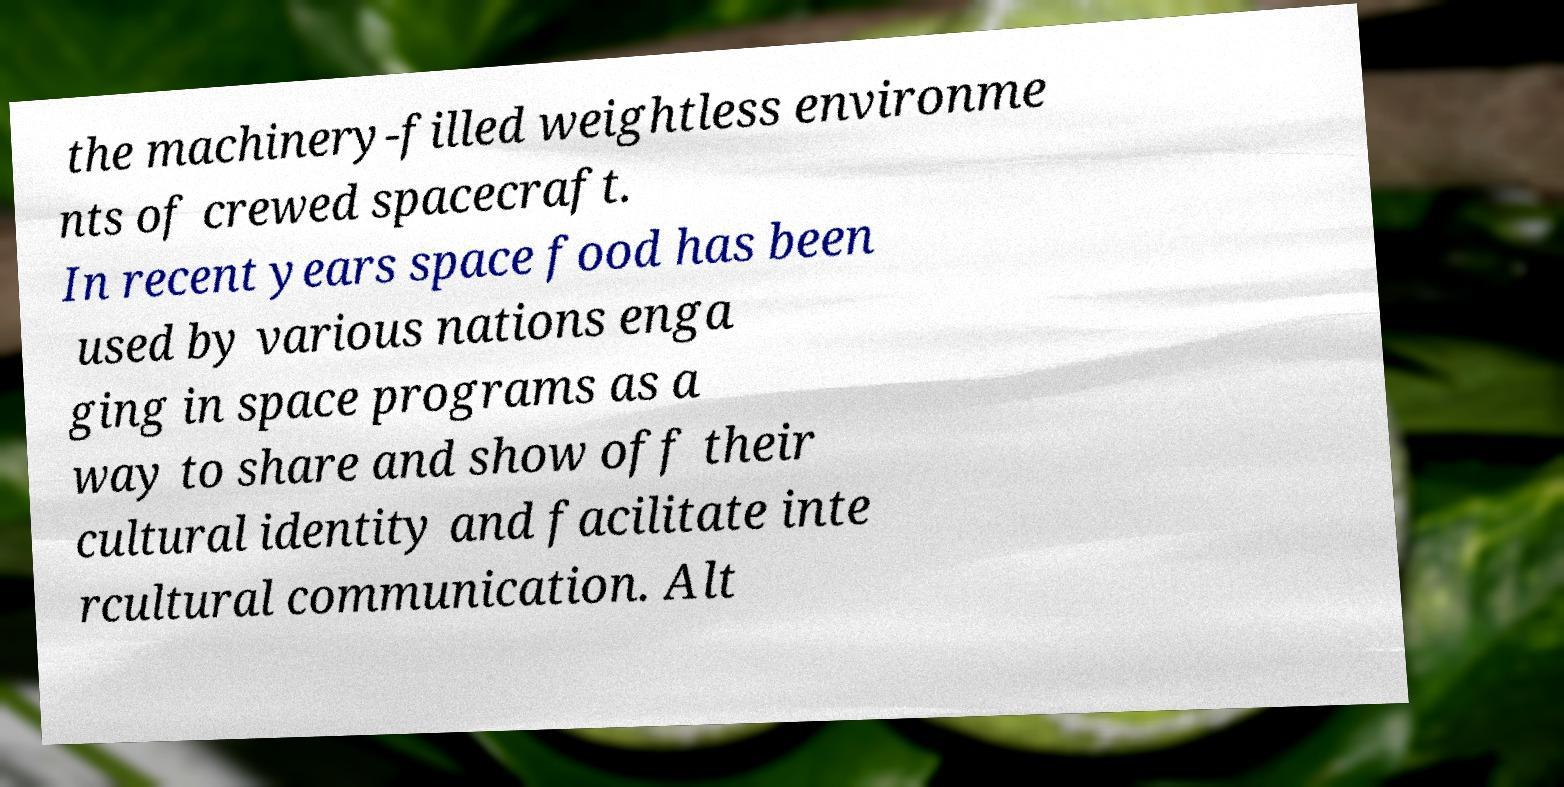I need the written content from this picture converted into text. Can you do that? the machinery-filled weightless environme nts of crewed spacecraft. In recent years space food has been used by various nations enga ging in space programs as a way to share and show off their cultural identity and facilitate inte rcultural communication. Alt 